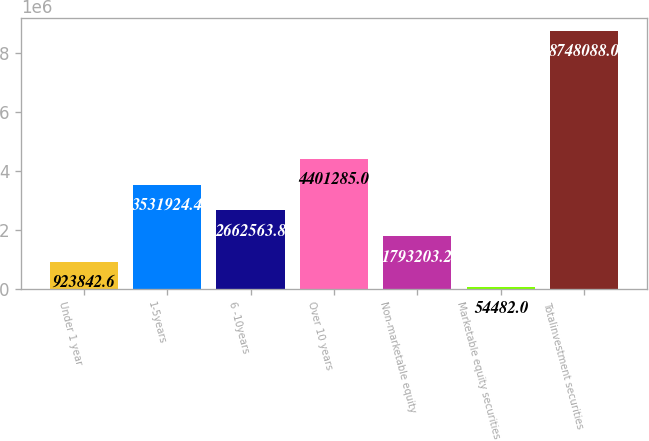<chart> <loc_0><loc_0><loc_500><loc_500><bar_chart><fcel>Under 1 year<fcel>1-5years<fcel>6 -10years<fcel>Over 10 years<fcel>Non-marketable equity<fcel>Marketable equity securities<fcel>Totalinvestment securities<nl><fcel>923843<fcel>3.53192e+06<fcel>2.66256e+06<fcel>4.40128e+06<fcel>1.7932e+06<fcel>54482<fcel>8.74809e+06<nl></chart> 